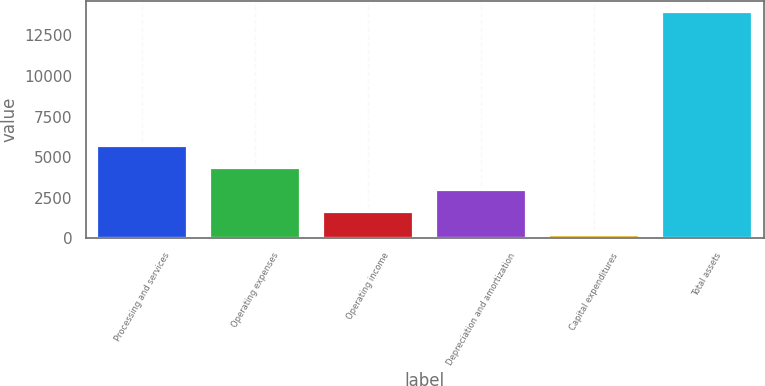Convert chart. <chart><loc_0><loc_0><loc_500><loc_500><bar_chart><fcel>Processing and services<fcel>Operating expenses<fcel>Operating income<fcel>Depreciation and amortization<fcel>Capital expenditures<fcel>Total assets<nl><fcel>5707.44<fcel>4332.98<fcel>1584.06<fcel>2958.52<fcel>209.6<fcel>13954.2<nl></chart> 